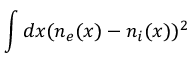<formula> <loc_0><loc_0><loc_500><loc_500>\int d x ( n _ { e } ( x ) - n _ { i } ( x ) ) ^ { 2 }</formula> 